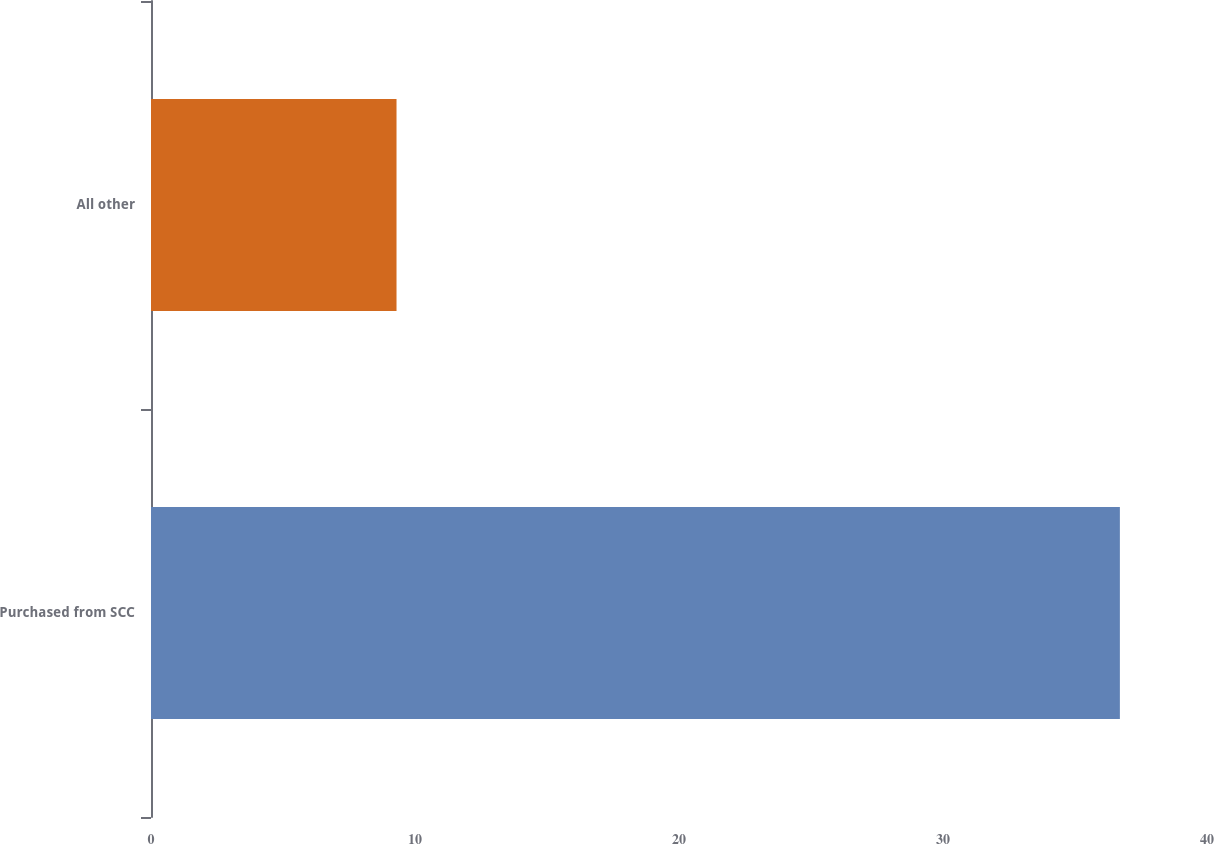Convert chart to OTSL. <chart><loc_0><loc_0><loc_500><loc_500><bar_chart><fcel>Purchased from SCC<fcel>All other<nl><fcel>36.7<fcel>9.3<nl></chart> 